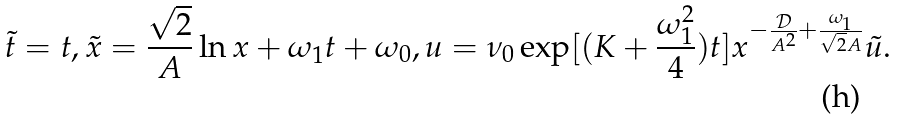Convert formula to latex. <formula><loc_0><loc_0><loc_500><loc_500>\tilde { t } = t , \tilde { x } = \frac { \sqrt { 2 } } { A } \ln x + \omega _ { 1 } t + \omega _ { 0 } , u = \nu _ { 0 } \exp [ ( K + \frac { \omega _ { 1 } ^ { 2 } } { 4 } ) t ] x ^ { - \frac { \mathcal { D } } { A ^ { 2 } } + \frac { \omega _ { 1 } } { \sqrt { 2 } A } } \tilde { u } .</formula> 